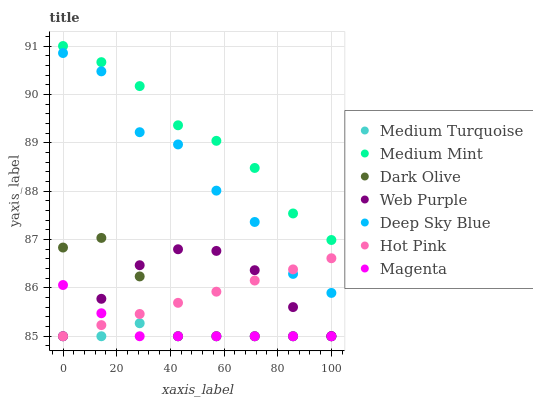Does Medium Turquoise have the minimum area under the curve?
Answer yes or no. Yes. Does Medium Mint have the maximum area under the curve?
Answer yes or no. Yes. Does Hot Pink have the minimum area under the curve?
Answer yes or no. No. Does Hot Pink have the maximum area under the curve?
Answer yes or no. No. Is Hot Pink the smoothest?
Answer yes or no. Yes. Is Deep Sky Blue the roughest?
Answer yes or no. Yes. Is Medium Turquoise the smoothest?
Answer yes or no. No. Is Medium Turquoise the roughest?
Answer yes or no. No. Does Hot Pink have the lowest value?
Answer yes or no. Yes. Does Deep Sky Blue have the lowest value?
Answer yes or no. No. Does Medium Mint have the highest value?
Answer yes or no. Yes. Does Hot Pink have the highest value?
Answer yes or no. No. Is Medium Turquoise less than Deep Sky Blue?
Answer yes or no. Yes. Is Medium Mint greater than Hot Pink?
Answer yes or no. Yes. Does Magenta intersect Dark Olive?
Answer yes or no. Yes. Is Magenta less than Dark Olive?
Answer yes or no. No. Is Magenta greater than Dark Olive?
Answer yes or no. No. Does Medium Turquoise intersect Deep Sky Blue?
Answer yes or no. No. 